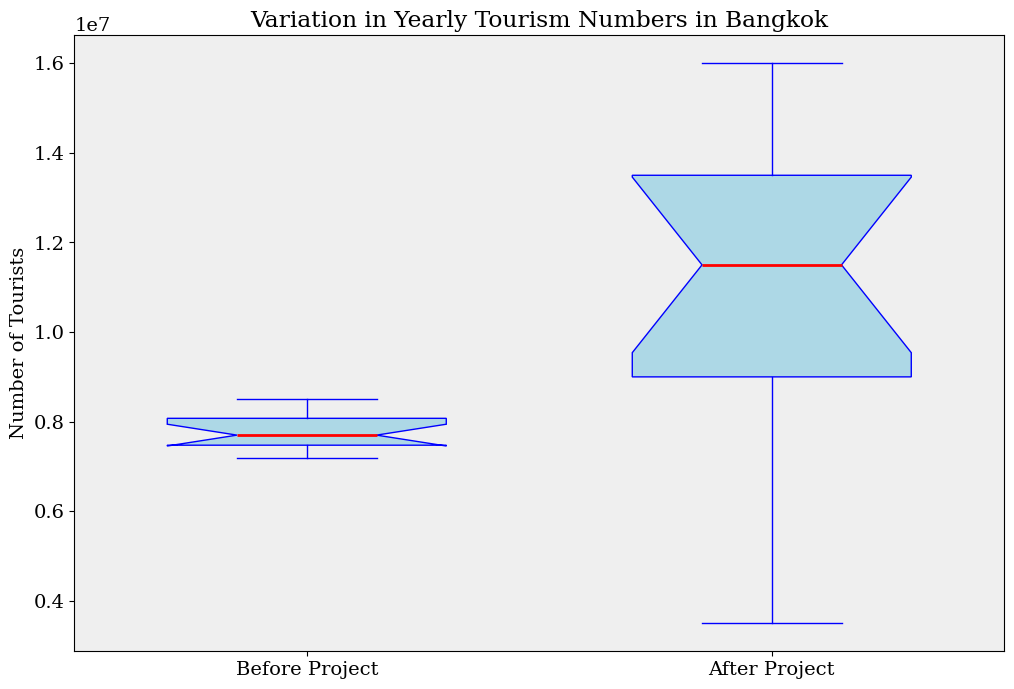How much higher is the median number of tourists after the project compared to before the project? To determine the median tourists in both periods, we observe the positions of the lines within the boxes. The red line (median) for the 'Before Project' period lies approximately along 7500000, while for the 'After Project' period, it appears around 10500000. The difference is 10500000 - 7500000.
Answer: 3000000 Which period, before or after the project, has a greater range of yearly tourist numbers? To find the range, we subtract the lower whisker value from the upper whisker value for both periods. The 'Before Project' whiskers span from about 7200000 to 8500000 (1300000), while the 'After Project' whiskers span from around 3500000 to 16000000 (12500000). The 'After Project' period has a greater range.
Answer: After Project What is the interquartile range (IQR) for the period after the project? IQR is computed by subtracting the lower quartile (Q1) from the upper quartile (Q3). For 'After Project', Q1 approximates to 8700000 and Q3 to 14000000, thus the IQR is 14000000 - 8700000.
Answer: 5300000 Are there any outliers present in either period, and if so, in which period? Outliers are typically marked as individual points beyond the whiskers. In the 'After Project' period, we notice points significantly lower than the lower whisker, implying outliers. There are no such points in the 'Before Project' period.
Answer: After Project What is the difference in the highest tourist number between the two periods? To find this, we observe the top of the whiskers. The 'Before Project' period has its highest value at 8500000 and the 'After Project' period at 16000000. The difference is 16000000 - 8500000.
Answer: 7500000 Which period shows more consistency in yearly tourism numbers? Consistency can be interpreted as smaller variation. The 'Before Project' box and whiskers are more compressed, suggesting less variance in tourist numbers compared to the 'After Project' period, which shows a far wider spread.
Answer: Before Project What color indicates the median in the figure? The median in the box plot is identified by the color of the middle line inside the boxes. This line is colored red.
Answer: Red What is the approximate lower quartile (Q1) value for the tourists after the project? The lower quartile (Q1) is indicated by the bottom of the light blue box for 'After Project', which is around 8700000 tourists.
Answer: 8700000 